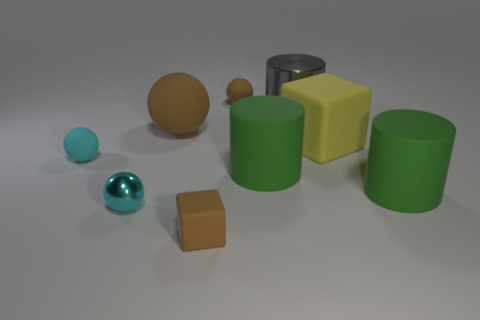What is the size of the other cyan thing that is the same shape as the small cyan rubber object? The other cyan object, which has the same spherical shape as the small cyan rubber object, appears to be approximately the same size, suggesting it is also small. 